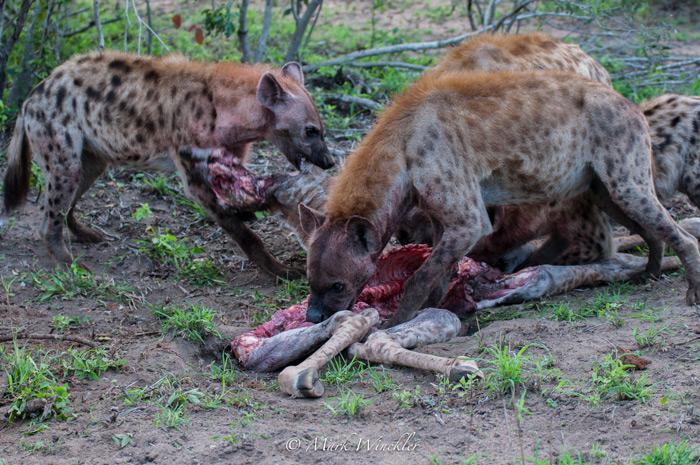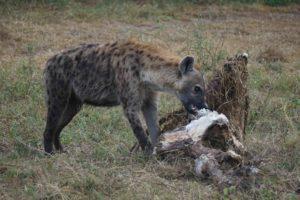The first image is the image on the left, the second image is the image on the right. Assess this claim about the two images: "Each image includes the carcass of a giraffe with at least some of its distinctively patterned hide intact, and the right image features a hyena with its head bent to the carcass.". Correct or not? Answer yes or no. No. The first image is the image on the left, the second image is the image on the right. Given the left and right images, does the statement "There are three brown and spotted hyenas  eat the carcass of a giraffe ." hold true? Answer yes or no. Yes. 